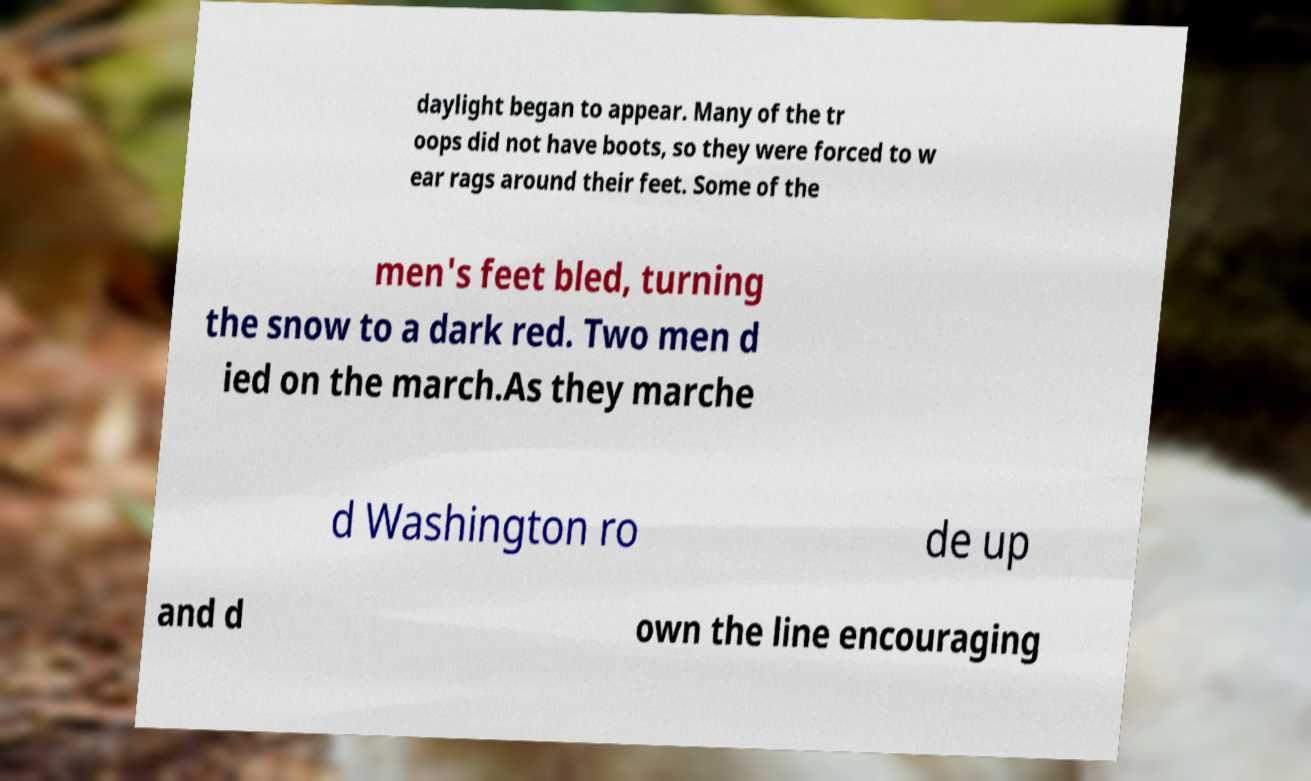Could you assist in decoding the text presented in this image and type it out clearly? daylight began to appear. Many of the tr oops did not have boots, so they were forced to w ear rags around their feet. Some of the men's feet bled, turning the snow to a dark red. Two men d ied on the march.As they marche d Washington ro de up and d own the line encouraging 